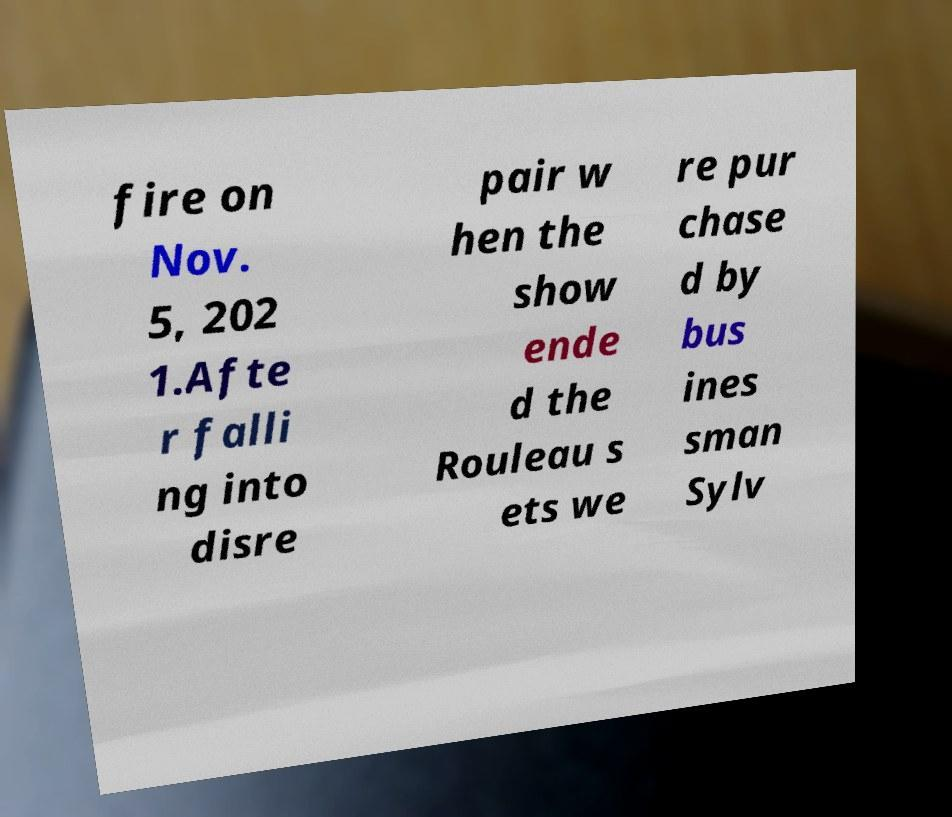For documentation purposes, I need the text within this image transcribed. Could you provide that? fire on Nov. 5, 202 1.Afte r falli ng into disre pair w hen the show ende d the Rouleau s ets we re pur chase d by bus ines sman Sylv 